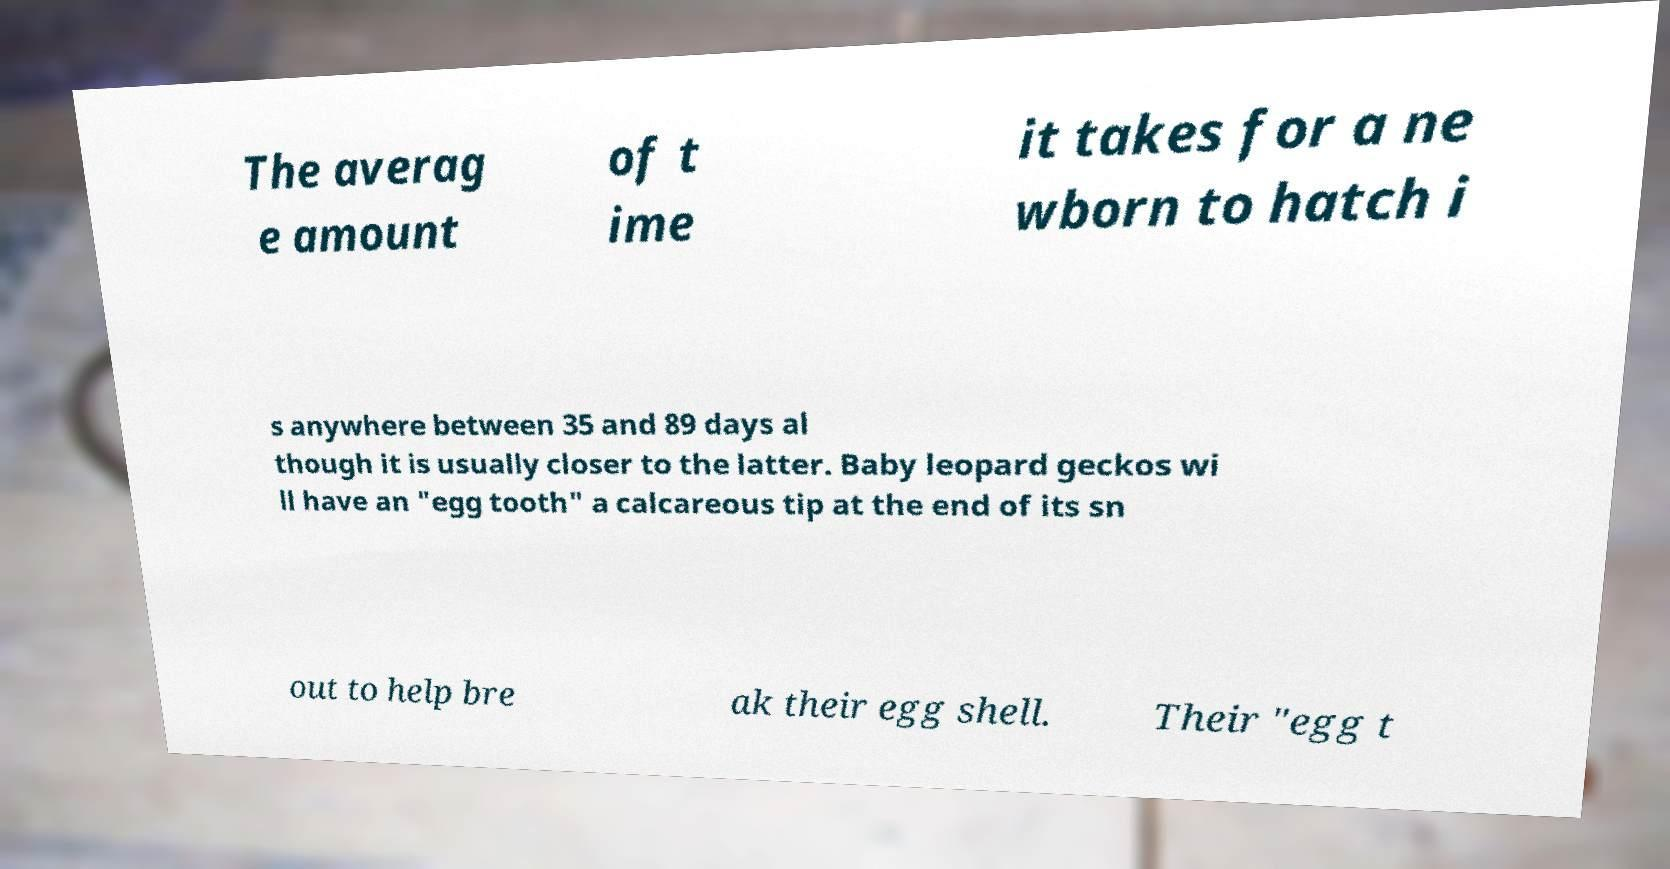Please read and relay the text visible in this image. What does it say? The averag e amount of t ime it takes for a ne wborn to hatch i s anywhere between 35 and 89 days al though it is usually closer to the latter. Baby leopard geckos wi ll have an "egg tooth" a calcareous tip at the end of its sn out to help bre ak their egg shell. Their "egg t 